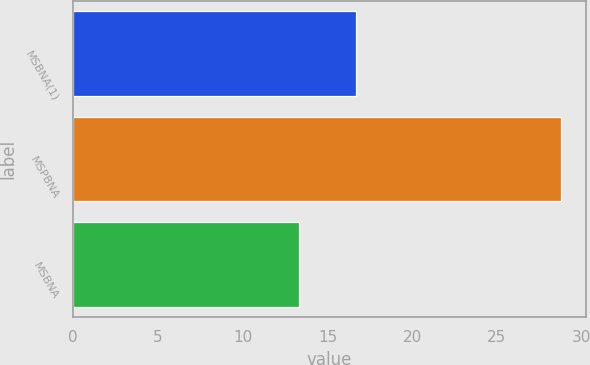<chart> <loc_0><loc_0><loc_500><loc_500><bar_chart><fcel>MSBNA(1)<fcel>MSPBNA<fcel>MSBNA<nl><fcel>16.7<fcel>28.8<fcel>13.3<nl></chart> 